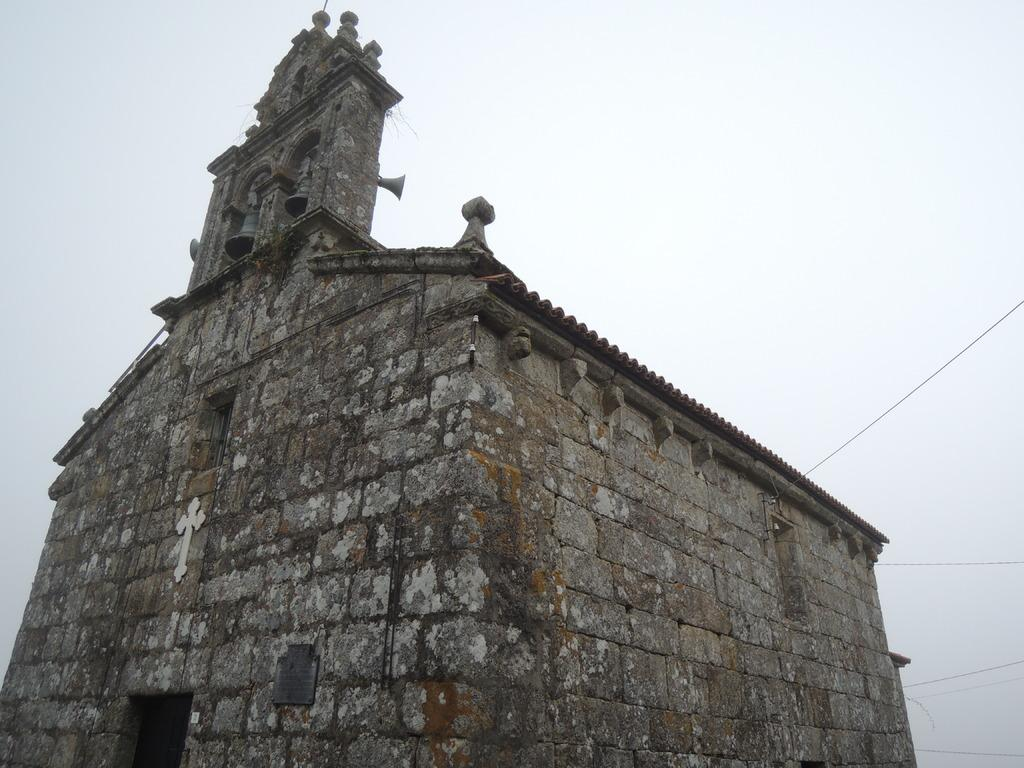What type of building is in the picture? There is an old church building in the picture. What can be seen in the background of the picture? The sky is visible behind the church building. What type of basketball court is visible in the picture? There is no basketball court present in the image; it features an old church building and the sky. How is the apple being distributed in the picture? There is no apple present in the image, so it cannot be distributed or involved in any distribution process. 